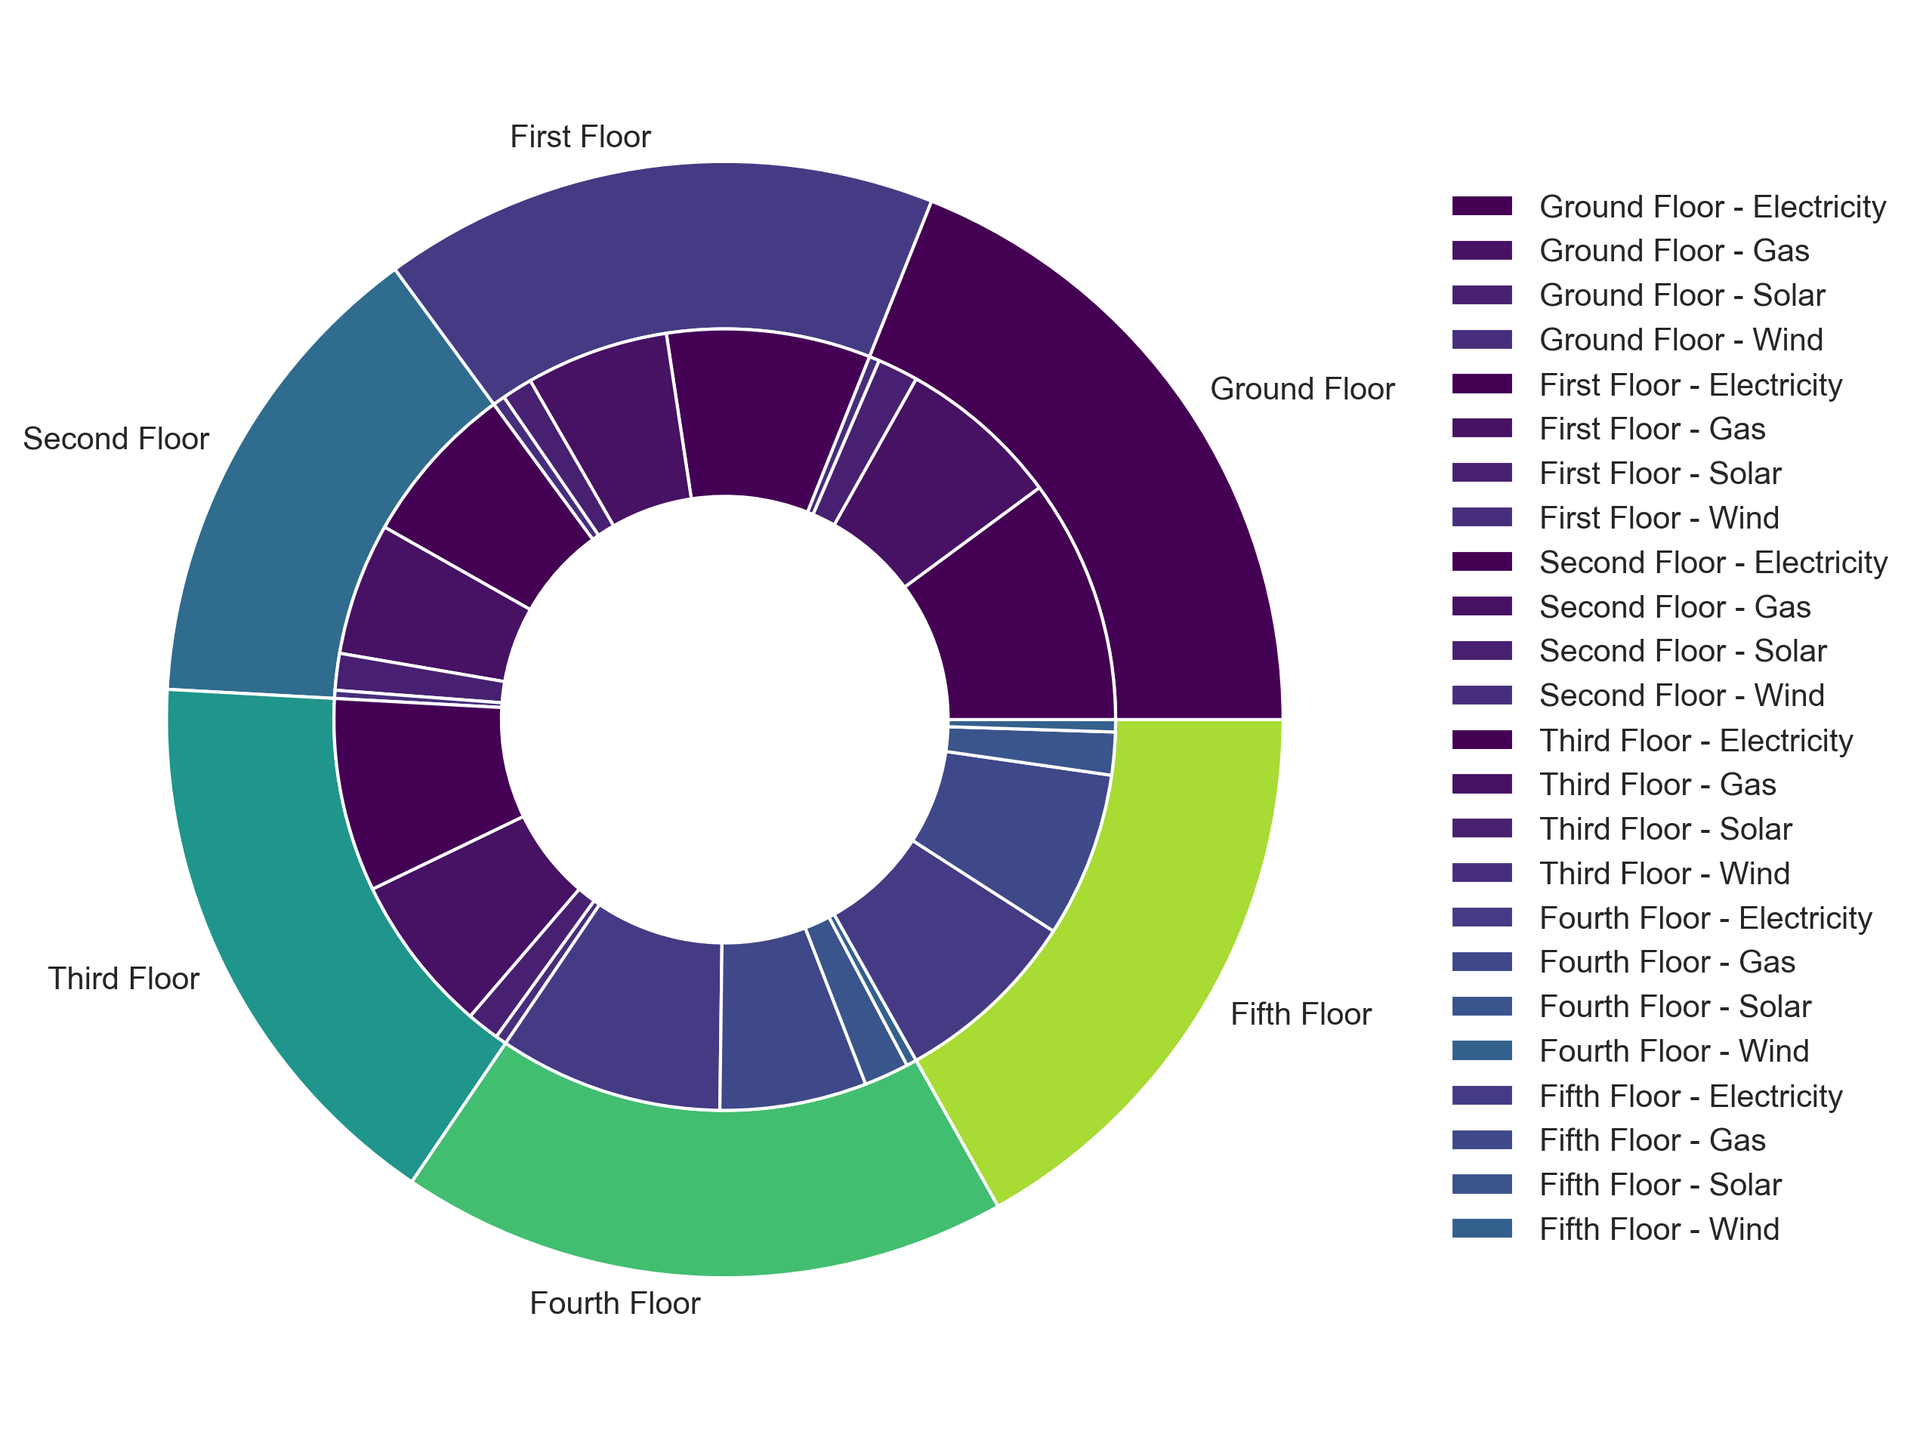What is the total energy consumption for the Ground Floor? To find the total energy consumption for the Ground Floor, sum the energy consumption for Electricity, Gas, Solar, and Wind on that floor. This is 12000 + 8000 + 2000 + 500.
Answer: 22500 kWh Which floor has the highest energy consumption from Gas? Compare the energy consumption from Gas among all floors. The data shows the following consumption in kWh: Ground Floor (8000), First Floor (7000), Second Floor (6500), Third Floor (7800), Fourth Floor (7200), Fifth Floor (8100). The Fifth Floor has the highest value.
Answer: Fifth Floor What is the combined energy consumption from Solar across all floors? Sum the energy consumption from Solar for each floor. This adds up the values: 2000 (Ground) + 1500 (First) + 1800 (Second) + 1600 (Third) + 2200 (Fourth) + 2100 (Fifth).
Answer: 11200 kWh Which energy source has the highest total consumption across all floors? Sum the energy consumption for each energy source across all floors. For Electricity: 59700 kWh, Gas: 44600 kWh, Solar: 11200 kWh, Wind: 3150 kWh. Electricity has the highest total consumption.
Answer: Electricity Does the Fourth Floor use more or less energy overall compared to the Third Floor? Sum the total energy consumption for the Fourth Floor (12000 + 7200 + 2200 + 500 = 20900 kWh) and the Third Floor (9500 + 7800 + 1600 + 550 = 19450 kWh). Compare the results.
Answer: More Which energy source on the Second Floor has the least consumption? Compare the energy consumptions for Electricity (8000), Gas (6500), Solar (1800), and Wind (400) on the Second Floor. Wind has the least consumption.
Answer: Wind How much more energy does the Ground Floor consume in Electricity compared to Wind? Subtract the energy consumption of Wind from that of Electricity on the Ground Floor: 12000 - 500.
Answer: 11500 kWh What is the average energy consumption from Gas per floor? Sum the total energy consumption from Gas across all floors: 44600 kWh. Divide this by the number of floors (6).
Answer: 7433.33 kWh Which visual segment represents the least amount of energy consumption and on which floor is it? Identify the smallest segment in the inner pie chart, which represents Wind on the Second Floor with 400 kWh.
Answer: Wind on Second Floor 